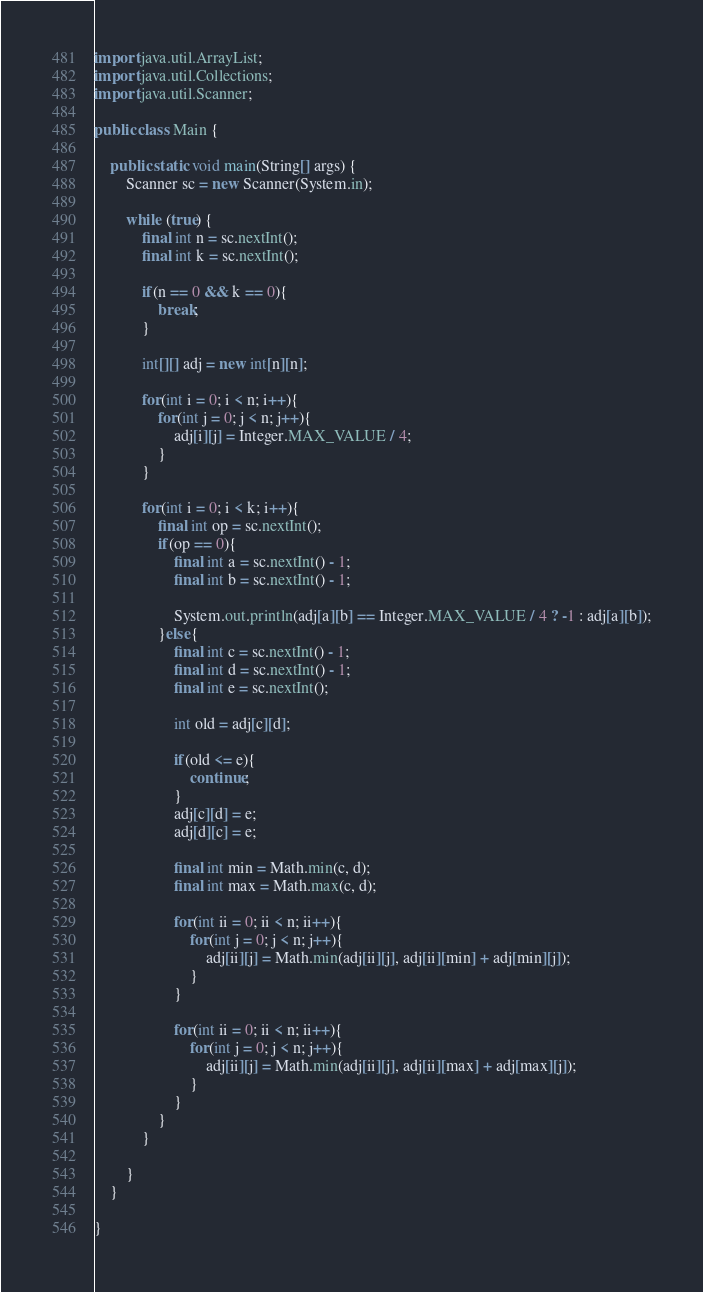Convert code to text. <code><loc_0><loc_0><loc_500><loc_500><_Java_>import java.util.ArrayList;
import java.util.Collections;
import java.util.Scanner;

public class Main {

	public static void main(String[] args) {
		Scanner sc = new Scanner(System.in);

		while (true) {
			final int n = sc.nextInt();
			final int k = sc.nextInt();
			
			if(n == 0 && k == 0){
				break;
			}
			
			int[][] adj = new int[n][n];
			
			for(int i = 0; i < n; i++){
				for(int j = 0; j < n; j++){
					adj[i][j] = Integer.MAX_VALUE / 4;
				}
			}
			
			for(int i = 0; i < k; i++){
				final int op = sc.nextInt();
				if(op == 0){
					final int a = sc.nextInt() - 1;
					final int b = sc.nextInt() - 1;
					
					System.out.println(adj[a][b] == Integer.MAX_VALUE / 4 ? -1 : adj[a][b]);
				}else{
					final int c = sc.nextInt() - 1;
					final int d = sc.nextInt() - 1;
					final int e = sc.nextInt();
					
					int old = adj[c][d];
					
					if(old <= e){
						continue;
					}
					adj[c][d] = e;
					adj[d][c] = e;
					
					final int min = Math.min(c, d);
					final int max = Math.max(c, d);
					
					for(int ii = 0; ii < n; ii++){
						for(int j = 0; j < n; j++){
							adj[ii][j] = Math.min(adj[ii][j], adj[ii][min] + adj[min][j]);
						}
					}
					
					for(int ii = 0; ii < n; ii++){
						for(int j = 0; j < n; j++){
							adj[ii][j] = Math.min(adj[ii][j], adj[ii][max] + adj[max][j]);
						}
					}
				}
			}
			
		}
	}

}</code> 